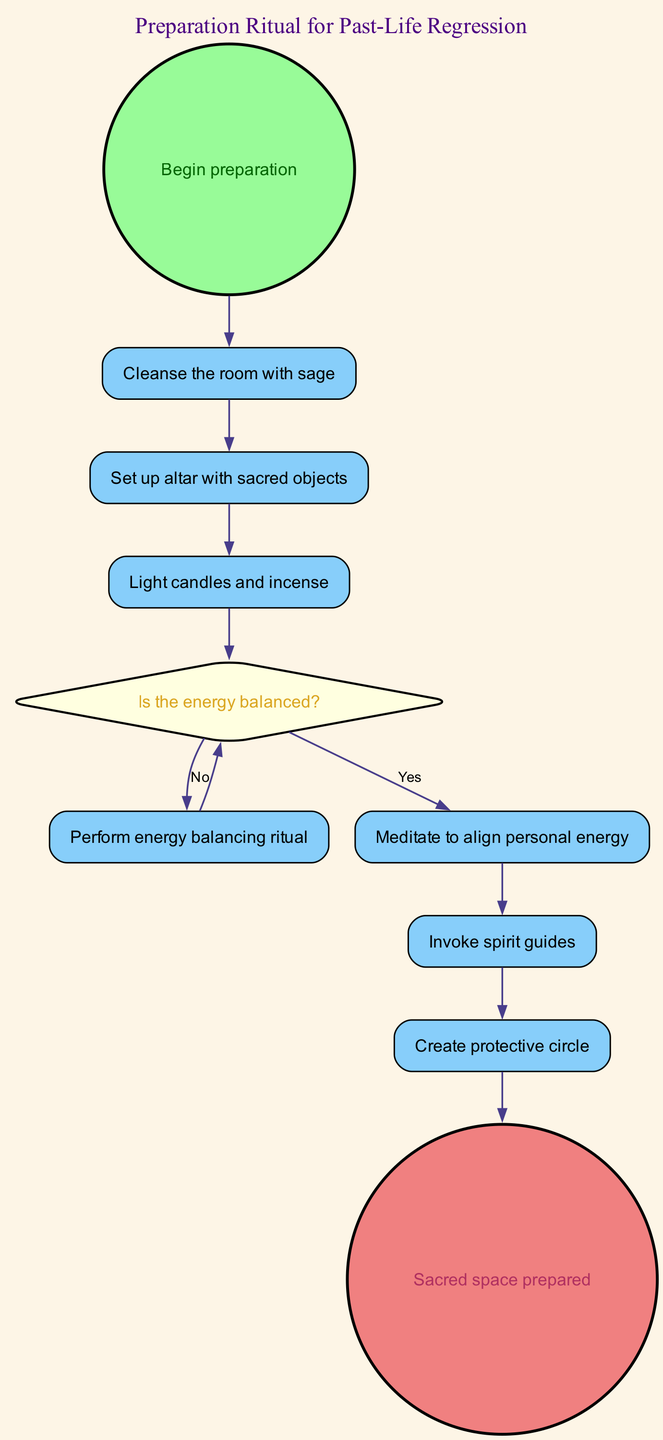What is the starting point of the preparation ritual? The diagram indicates that the preparation ritual begins with the "Begin preparation" node, which is the first activity represented.
Answer: Begin preparation How many activities are there in the preparation ritual? By counting the activity nodes in the diagram, we find there are five activities: "Cleanse the room with sage," "Set up altar with sacred objects," "Light candles and incense," "Perform energy balancing ritual," and "Meditate to align personal energy."
Answer: Five What do you do after lighting candles and incense? The flow of the diagram shows that after "Light candles and incense," the next action is to check if the energy is balanced by moving to the "Is the energy balanced?" decision node.
Answer: Is the energy balanced? If the energy is not balanced, what is the next step to take? The diagram illustrates that if the answer to "Is the energy balanced?" is "No," you proceed to "Perform energy balancing ritual," before reassessing the energy balance again.
Answer: Perform energy balancing ritual What is the final step in the preparation ritual? According to the diagram, the last activity that concludes the preparation ritual is "Sacred space prepared," which marks the completion of the process.
Answer: Sacred space prepared What decision must be made after lighting candles and incense? After "Light candles and incense," the next step on the diagram is to determine whether the energy is balanced, represented by the decision node "Is the energy balanced?"
Answer: Is the energy balanced? How does the process flow if the energy is balanced? If the energy is balanced ("Yes"), the next activity in the flow after the decision node is "Meditate to align personal energy," leading to subsequent actions until completion.
Answer: Meditate to align personal energy What activity follows invoking spirit guides? After "Invoke spirit guides," the next activity in the sequence is "Create protective circle," as shown by the directed flow of the diagram.
Answer: Create protective circle 